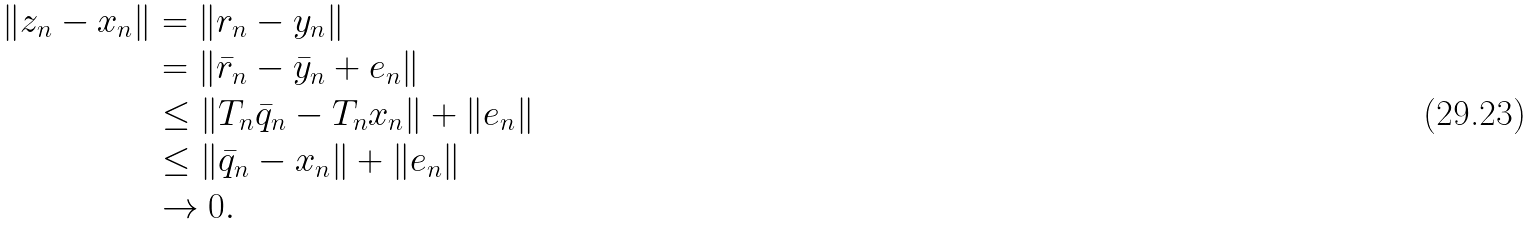Convert formula to latex. <formula><loc_0><loc_0><loc_500><loc_500>\| z _ { n } - x _ { n } \| & = \| r _ { n } - y _ { n } \| \\ & = \| \bar { r } _ { n } - \bar { y } _ { n } + e _ { n } \| \\ & \leq \| T _ { n } \bar { q } _ { n } - T _ { n } x _ { n } \| + \| e _ { n } \| \\ & \leq \| \bar { q } _ { n } - x _ { n } \| + \| e _ { n } \| \\ & \to 0 .</formula> 